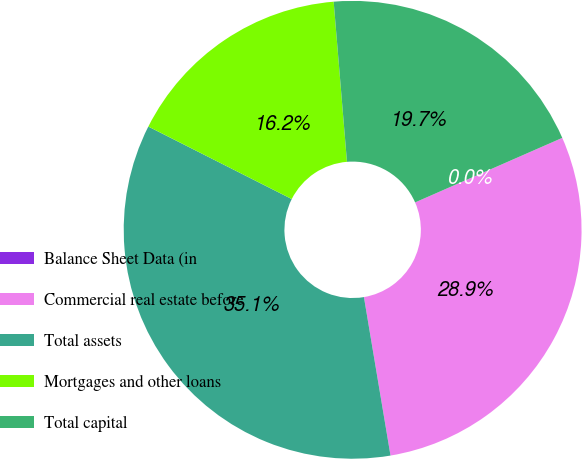<chart> <loc_0><loc_0><loc_500><loc_500><pie_chart><fcel>Balance Sheet Data (in<fcel>Commercial real estate before<fcel>Total assets<fcel>Mortgages and other loans<fcel>Total capital<nl><fcel>0.0%<fcel>28.93%<fcel>35.09%<fcel>16.23%<fcel>19.74%<nl></chart> 